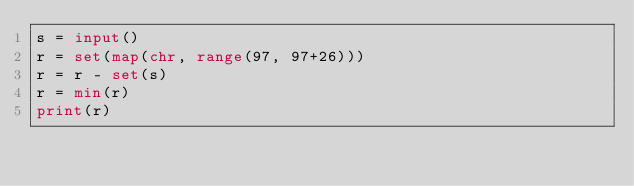<code> <loc_0><loc_0><loc_500><loc_500><_Python_>s = input()
r = set(map(chr, range(97, 97+26)))
r = r - set(s)
r = min(r)
print(r)</code> 